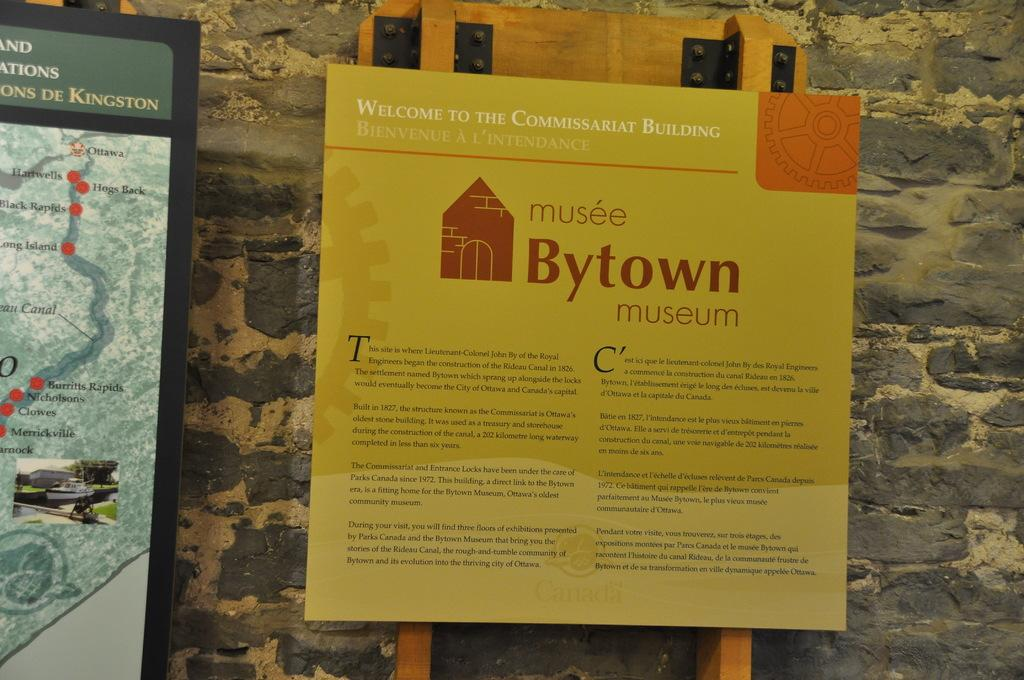<image>
Offer a succinct explanation of the picture presented. A sign posted on a stone wall welcomes visitors to a specific section of the Musee Bytown Museum. 